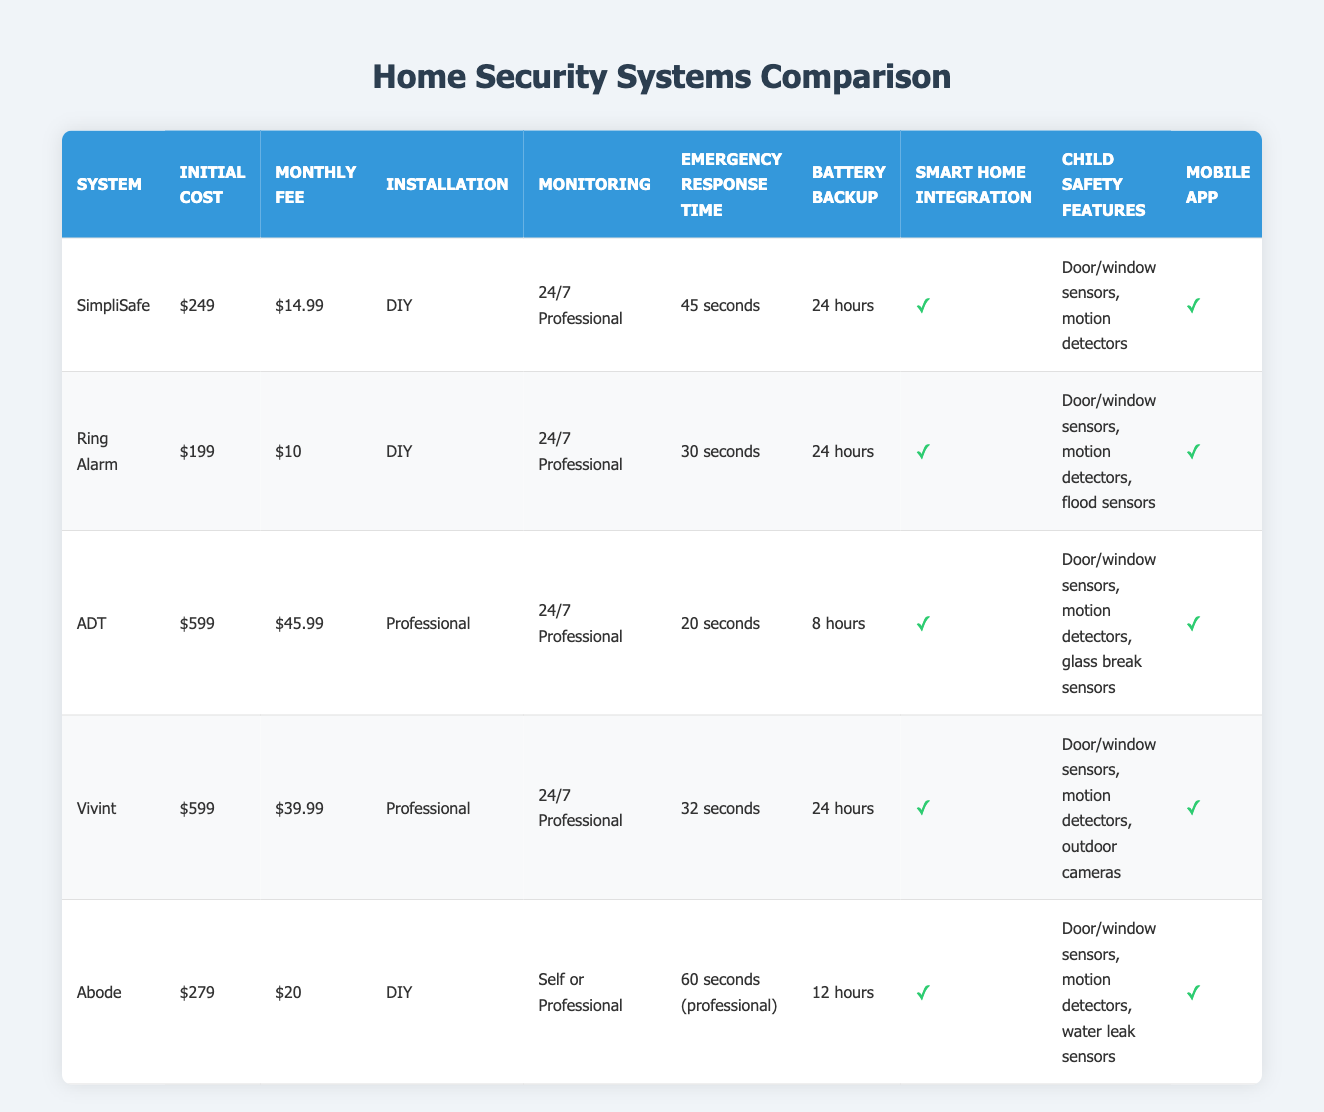What is the lowest initial cost among the security systems? The initial costs in the table are: SimpliSafe - $249, Ring Alarm - $199, ADT - $599, Vivint - $599, and Abode - $279. The lowest of these amounts is $199 for the Ring Alarm.
Answer: $199 Which system provides the fastest emergency response time? The emergency response times listed are: SimpliSafe - 45 seconds, Ring Alarm - 30 seconds, ADT - 20 seconds, Vivint - 32 seconds, and Abode - 60 seconds. The fastest time is 20 seconds for ADT.
Answer: 20 seconds Is there a system that can integrate with smart home devices? All systems listed have smart home integration except for none, which is notable. The table shows "Yes" under the smart home integration column for all systems: SimpliSafe, Ring Alarm, ADT, Vivint, and Abode.
Answer: Yes What is the difference in monthly fees between ADT and Ring Alarm? The monthly fees for ADT and Ring Alarm are $45.99 and $10 respectively. To find the difference, subtract Ring Alarm's fee from ADT's: $45.99 - $10 = $35.99.
Answer: $35.99 Which security system has child safety features related to flood sensors? The systems with child safety features are: SimpliSafe with door/window sensors and motion detectors, Ring Alarm with door/window sensors, motion detectors, and flood sensors, ADT with glass break sensors, Vivint with outdoor cameras, and Abode with water leak sensors. The system with flood sensors is Ring Alarm.
Answer: Ring Alarm How long is the battery backup for Vivint compared to ADT? Vivint has a battery backup of 24 hours, while ADT has only 8 hours. Thus, Vivint's backup duration is longer than ADT's.
Answer: 24 hours for Vivint and 8 hours for ADT What percentage of the listed systems have a mobile app feature? There are 5 systems total: SimpliSafe, Ring Alarm, ADT, Vivint, and Abode. All of them have a mobile app feature, which means 100 percent of the systems include this option, calculated as (5/5) * 100 = 100%.
Answer: 100% 